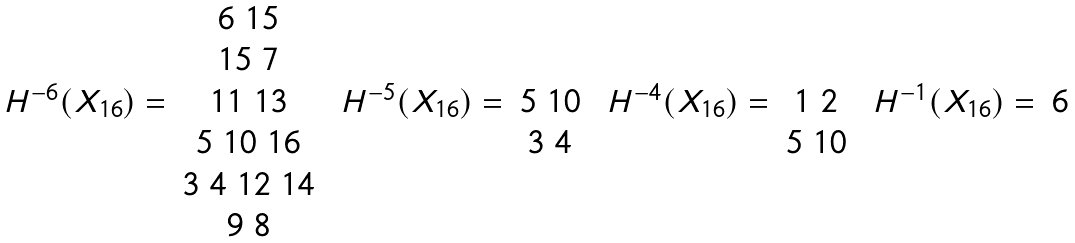<formula> <loc_0><loc_0><loc_500><loc_500>\begin{array} { c c } & 6 \ 1 5 \\ & 1 5 \ 7 \\ H ^ { - 6 } ( X _ { 1 6 } ) = & 1 1 \ 1 3 \\ & 5 \ 1 0 \ 1 6 \\ & 3 \ 4 \ 1 2 \ 1 4 \\ & 9 \ 8 \\ \end{array} \ \begin{array} { c c } & \\ & \\ H ^ { - 5 } ( X _ { 1 6 } ) = & 5 \ 1 0 \\ & 3 \ 4 \\ & \\ & \\ \end{array} \ \begin{array} { c c } & \\ & \\ H ^ { - 4 } ( X _ { 1 6 } ) = & 1 \ 2 \\ & 5 \ 1 0 \\ & \\ & \\ \end{array} \ \begin{array} { c c } & \\ & \\ H ^ { - 1 } ( X _ { 1 6 } ) = & 6 \\ & \\ & \\ & \\ \end{array}</formula> 